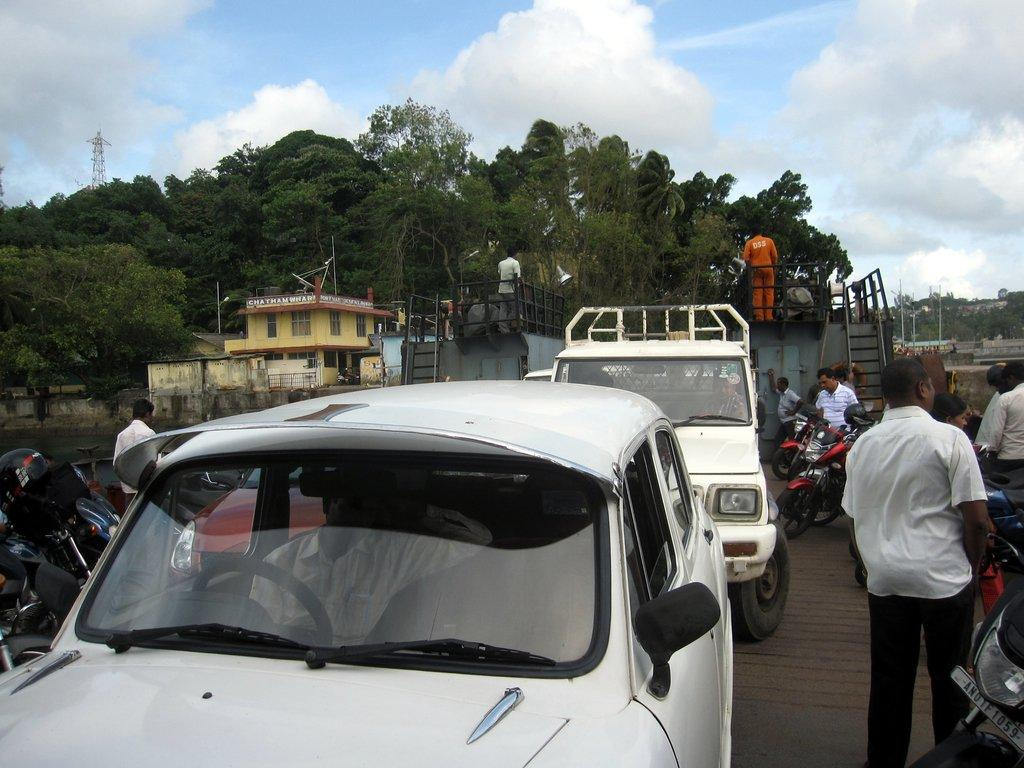What type of pole can be seen in the image? There is a current pole in the image. What can be seen in the sky in the image? The sky is visible in the image. What type of vegetation is present in the image? There are trees in the image. What type of structures can be seen in the image? There are buildings in the image. What type of vehicles are present in the image? Motorcycles and cars are visible in the image. Are there any people in the image? Yes, there are people standing in the image. How much profit does the thumb generate in the image? There is no thumb present in the image, and therefore no profit can be generated from it. 